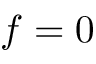Convert formula to latex. <formula><loc_0><loc_0><loc_500><loc_500>f = 0</formula> 